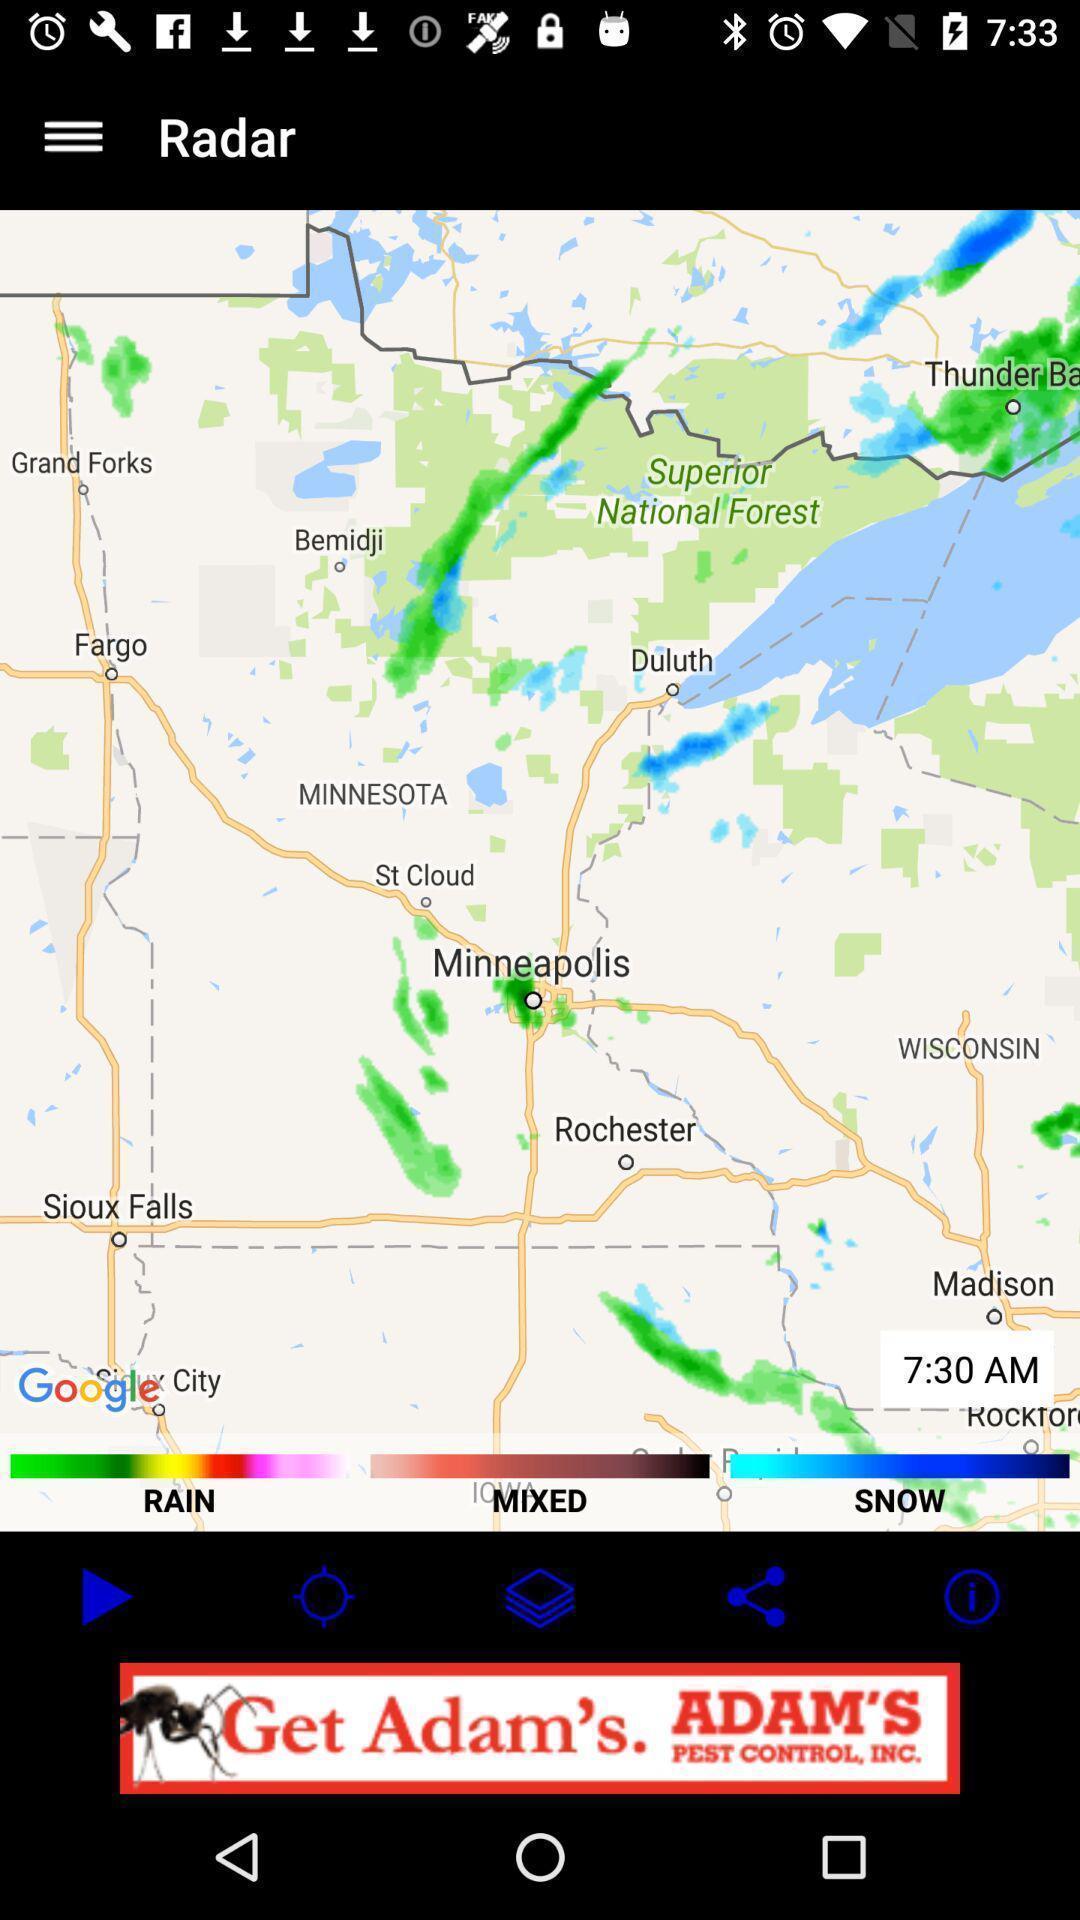Describe the content in this image. Page displays weather in app. 